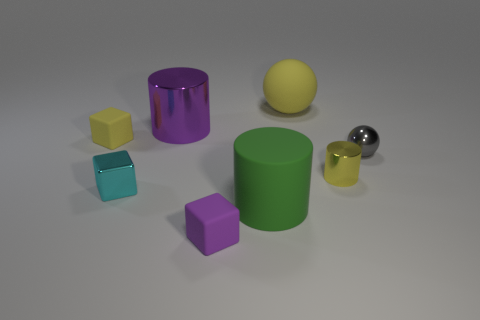Are there any purple objects right of the purple cylinder?
Keep it short and to the point. Yes. How many other things are the same size as the cyan object?
Offer a terse response. 4. There is a thing that is both left of the green object and in front of the tiny shiny cube; what material is it?
Provide a short and direct response. Rubber. Is the shape of the large thing in front of the gray shiny thing the same as the yellow rubber thing that is on the left side of the metallic block?
Provide a short and direct response. No. Is there anything else that is made of the same material as the big green object?
Give a very brief answer. Yes. There is a large rubber object behind the tiny yellow thing that is right of the small yellow thing on the left side of the cyan block; what shape is it?
Give a very brief answer. Sphere. What number of other objects are there of the same shape as the big shiny object?
Your response must be concise. 2. There is a cylinder that is the same size as the metallic cube; what color is it?
Your answer should be very brief. Yellow. What number of cubes are either rubber things or cyan objects?
Provide a short and direct response. 3. How many brown matte things are there?
Keep it short and to the point. 0. 